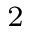<formula> <loc_0><loc_0><loc_500><loc_500>_ { 2 }</formula> 